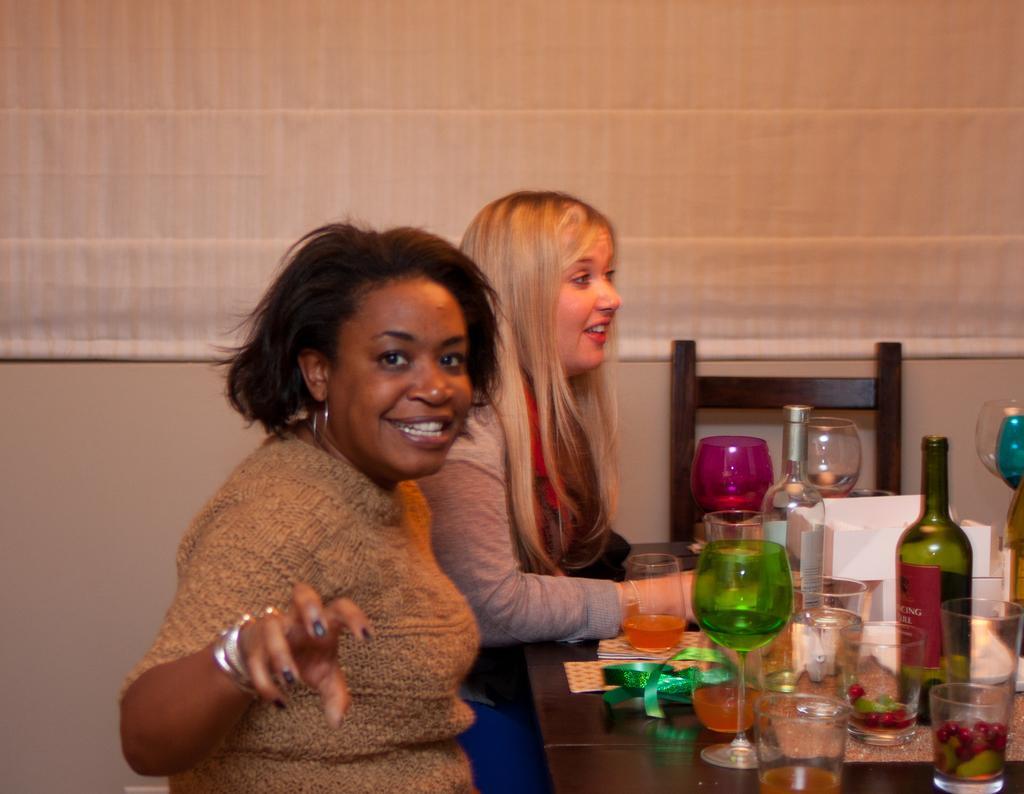Can you describe this image briefly? In the image we can see there are woman who are sitting on chair and on table there are wine bottle wine glasses. 